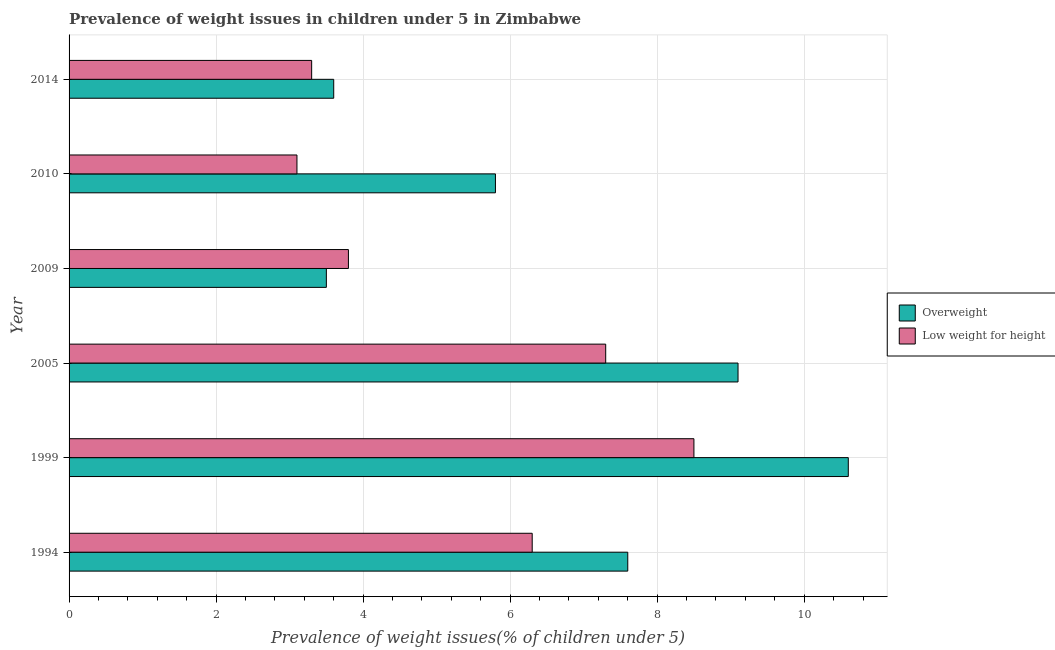How many different coloured bars are there?
Make the answer very short. 2. How many groups of bars are there?
Your response must be concise. 6. How many bars are there on the 4th tick from the top?
Give a very brief answer. 2. What is the percentage of underweight children in 2010?
Your answer should be compact. 3.1. Across all years, what is the maximum percentage of overweight children?
Make the answer very short. 10.6. Across all years, what is the minimum percentage of underweight children?
Ensure brevity in your answer.  3.1. In which year was the percentage of underweight children maximum?
Your answer should be compact. 1999. In which year was the percentage of underweight children minimum?
Offer a terse response. 2010. What is the total percentage of overweight children in the graph?
Your answer should be very brief. 40.2. What is the difference between the percentage of underweight children in 1994 and that in 2009?
Keep it short and to the point. 2.5. What is the difference between the percentage of underweight children in 1994 and the percentage of overweight children in 2010?
Your answer should be compact. 0.5. In the year 1994, what is the difference between the percentage of underweight children and percentage of overweight children?
Provide a short and direct response. -1.3. In how many years, is the percentage of overweight children greater than 2.4 %?
Make the answer very short. 6. What is the ratio of the percentage of underweight children in 2009 to that in 2014?
Give a very brief answer. 1.15. Is the difference between the percentage of overweight children in 1994 and 2014 greater than the difference between the percentage of underweight children in 1994 and 2014?
Give a very brief answer. Yes. What is the difference between the highest and the second highest percentage of overweight children?
Keep it short and to the point. 1.5. Is the sum of the percentage of overweight children in 2010 and 2014 greater than the maximum percentage of underweight children across all years?
Give a very brief answer. Yes. What does the 1st bar from the top in 1999 represents?
Provide a short and direct response. Low weight for height. What does the 1st bar from the bottom in 1999 represents?
Provide a succinct answer. Overweight. How many bars are there?
Provide a succinct answer. 12. Are all the bars in the graph horizontal?
Provide a short and direct response. Yes. How many years are there in the graph?
Offer a very short reply. 6. Are the values on the major ticks of X-axis written in scientific E-notation?
Your answer should be very brief. No. Does the graph contain any zero values?
Make the answer very short. No. Where does the legend appear in the graph?
Offer a very short reply. Center right. How many legend labels are there?
Offer a terse response. 2. How are the legend labels stacked?
Offer a terse response. Vertical. What is the title of the graph?
Your answer should be very brief. Prevalence of weight issues in children under 5 in Zimbabwe. What is the label or title of the X-axis?
Your answer should be compact. Prevalence of weight issues(% of children under 5). What is the label or title of the Y-axis?
Your response must be concise. Year. What is the Prevalence of weight issues(% of children under 5) of Overweight in 1994?
Make the answer very short. 7.6. What is the Prevalence of weight issues(% of children under 5) of Low weight for height in 1994?
Your answer should be very brief. 6.3. What is the Prevalence of weight issues(% of children under 5) in Overweight in 1999?
Your response must be concise. 10.6. What is the Prevalence of weight issues(% of children under 5) of Overweight in 2005?
Your response must be concise. 9.1. What is the Prevalence of weight issues(% of children under 5) of Low weight for height in 2005?
Provide a short and direct response. 7.3. What is the Prevalence of weight issues(% of children under 5) in Overweight in 2009?
Ensure brevity in your answer.  3.5. What is the Prevalence of weight issues(% of children under 5) in Low weight for height in 2009?
Give a very brief answer. 3.8. What is the Prevalence of weight issues(% of children under 5) of Overweight in 2010?
Provide a succinct answer. 5.8. What is the Prevalence of weight issues(% of children under 5) of Low weight for height in 2010?
Your answer should be compact. 3.1. What is the Prevalence of weight issues(% of children under 5) in Overweight in 2014?
Give a very brief answer. 3.6. What is the Prevalence of weight issues(% of children under 5) in Low weight for height in 2014?
Keep it short and to the point. 3.3. Across all years, what is the maximum Prevalence of weight issues(% of children under 5) in Overweight?
Provide a short and direct response. 10.6. Across all years, what is the maximum Prevalence of weight issues(% of children under 5) of Low weight for height?
Provide a short and direct response. 8.5. Across all years, what is the minimum Prevalence of weight issues(% of children under 5) of Overweight?
Your answer should be compact. 3.5. Across all years, what is the minimum Prevalence of weight issues(% of children under 5) of Low weight for height?
Make the answer very short. 3.1. What is the total Prevalence of weight issues(% of children under 5) of Overweight in the graph?
Your response must be concise. 40.2. What is the total Prevalence of weight issues(% of children under 5) in Low weight for height in the graph?
Make the answer very short. 32.3. What is the difference between the Prevalence of weight issues(% of children under 5) of Overweight in 1994 and that in 1999?
Your response must be concise. -3. What is the difference between the Prevalence of weight issues(% of children under 5) in Overweight in 1994 and that in 2009?
Provide a short and direct response. 4.1. What is the difference between the Prevalence of weight issues(% of children under 5) of Overweight in 1994 and that in 2010?
Provide a succinct answer. 1.8. What is the difference between the Prevalence of weight issues(% of children under 5) of Low weight for height in 1994 and that in 2014?
Ensure brevity in your answer.  3. What is the difference between the Prevalence of weight issues(% of children under 5) in Low weight for height in 1999 and that in 2009?
Make the answer very short. 4.7. What is the difference between the Prevalence of weight issues(% of children under 5) of Overweight in 2005 and that in 2009?
Ensure brevity in your answer.  5.6. What is the difference between the Prevalence of weight issues(% of children under 5) in Low weight for height in 2005 and that in 2009?
Your answer should be compact. 3.5. What is the difference between the Prevalence of weight issues(% of children under 5) in Overweight in 2005 and that in 2010?
Make the answer very short. 3.3. What is the difference between the Prevalence of weight issues(% of children under 5) in Low weight for height in 2005 and that in 2010?
Your answer should be compact. 4.2. What is the difference between the Prevalence of weight issues(% of children under 5) in Overweight in 2005 and that in 2014?
Your answer should be very brief. 5.5. What is the difference between the Prevalence of weight issues(% of children under 5) in Overweight in 2009 and that in 2010?
Provide a short and direct response. -2.3. What is the difference between the Prevalence of weight issues(% of children under 5) of Overweight in 2009 and that in 2014?
Your answer should be compact. -0.1. What is the difference between the Prevalence of weight issues(% of children under 5) of Low weight for height in 2009 and that in 2014?
Ensure brevity in your answer.  0.5. What is the difference between the Prevalence of weight issues(% of children under 5) of Low weight for height in 2010 and that in 2014?
Give a very brief answer. -0.2. What is the difference between the Prevalence of weight issues(% of children under 5) of Overweight in 1994 and the Prevalence of weight issues(% of children under 5) of Low weight for height in 2005?
Make the answer very short. 0.3. What is the difference between the Prevalence of weight issues(% of children under 5) in Overweight in 1994 and the Prevalence of weight issues(% of children under 5) in Low weight for height in 2009?
Your response must be concise. 3.8. What is the difference between the Prevalence of weight issues(% of children under 5) of Overweight in 1994 and the Prevalence of weight issues(% of children under 5) of Low weight for height in 2010?
Offer a very short reply. 4.5. What is the difference between the Prevalence of weight issues(% of children under 5) in Overweight in 1994 and the Prevalence of weight issues(% of children under 5) in Low weight for height in 2014?
Keep it short and to the point. 4.3. What is the difference between the Prevalence of weight issues(% of children under 5) of Overweight in 1999 and the Prevalence of weight issues(% of children under 5) of Low weight for height in 2005?
Your answer should be very brief. 3.3. What is the difference between the Prevalence of weight issues(% of children under 5) in Overweight in 1999 and the Prevalence of weight issues(% of children under 5) in Low weight for height in 2009?
Give a very brief answer. 6.8. What is the difference between the Prevalence of weight issues(% of children under 5) in Overweight in 2005 and the Prevalence of weight issues(% of children under 5) in Low weight for height in 2009?
Offer a terse response. 5.3. What is the difference between the Prevalence of weight issues(% of children under 5) in Overweight in 2009 and the Prevalence of weight issues(% of children under 5) in Low weight for height in 2014?
Your answer should be compact. 0.2. What is the difference between the Prevalence of weight issues(% of children under 5) in Overweight in 2010 and the Prevalence of weight issues(% of children under 5) in Low weight for height in 2014?
Offer a terse response. 2.5. What is the average Prevalence of weight issues(% of children under 5) in Low weight for height per year?
Give a very brief answer. 5.38. In the year 1994, what is the difference between the Prevalence of weight issues(% of children under 5) of Overweight and Prevalence of weight issues(% of children under 5) of Low weight for height?
Your answer should be very brief. 1.3. In the year 2010, what is the difference between the Prevalence of weight issues(% of children under 5) of Overweight and Prevalence of weight issues(% of children under 5) of Low weight for height?
Offer a very short reply. 2.7. In the year 2014, what is the difference between the Prevalence of weight issues(% of children under 5) in Overweight and Prevalence of weight issues(% of children under 5) in Low weight for height?
Your response must be concise. 0.3. What is the ratio of the Prevalence of weight issues(% of children under 5) in Overweight in 1994 to that in 1999?
Provide a succinct answer. 0.72. What is the ratio of the Prevalence of weight issues(% of children under 5) in Low weight for height in 1994 to that in 1999?
Your response must be concise. 0.74. What is the ratio of the Prevalence of weight issues(% of children under 5) of Overweight in 1994 to that in 2005?
Your answer should be compact. 0.84. What is the ratio of the Prevalence of weight issues(% of children under 5) of Low weight for height in 1994 to that in 2005?
Offer a very short reply. 0.86. What is the ratio of the Prevalence of weight issues(% of children under 5) in Overweight in 1994 to that in 2009?
Your answer should be compact. 2.17. What is the ratio of the Prevalence of weight issues(% of children under 5) of Low weight for height in 1994 to that in 2009?
Your response must be concise. 1.66. What is the ratio of the Prevalence of weight issues(% of children under 5) in Overweight in 1994 to that in 2010?
Make the answer very short. 1.31. What is the ratio of the Prevalence of weight issues(% of children under 5) of Low weight for height in 1994 to that in 2010?
Ensure brevity in your answer.  2.03. What is the ratio of the Prevalence of weight issues(% of children under 5) of Overweight in 1994 to that in 2014?
Your answer should be compact. 2.11. What is the ratio of the Prevalence of weight issues(% of children under 5) of Low weight for height in 1994 to that in 2014?
Ensure brevity in your answer.  1.91. What is the ratio of the Prevalence of weight issues(% of children under 5) in Overweight in 1999 to that in 2005?
Offer a very short reply. 1.16. What is the ratio of the Prevalence of weight issues(% of children under 5) of Low weight for height in 1999 to that in 2005?
Provide a short and direct response. 1.16. What is the ratio of the Prevalence of weight issues(% of children under 5) of Overweight in 1999 to that in 2009?
Provide a succinct answer. 3.03. What is the ratio of the Prevalence of weight issues(% of children under 5) in Low weight for height in 1999 to that in 2009?
Provide a succinct answer. 2.24. What is the ratio of the Prevalence of weight issues(% of children under 5) of Overweight in 1999 to that in 2010?
Offer a terse response. 1.83. What is the ratio of the Prevalence of weight issues(% of children under 5) of Low weight for height in 1999 to that in 2010?
Offer a terse response. 2.74. What is the ratio of the Prevalence of weight issues(% of children under 5) in Overweight in 1999 to that in 2014?
Make the answer very short. 2.94. What is the ratio of the Prevalence of weight issues(% of children under 5) of Low weight for height in 1999 to that in 2014?
Ensure brevity in your answer.  2.58. What is the ratio of the Prevalence of weight issues(% of children under 5) in Low weight for height in 2005 to that in 2009?
Provide a short and direct response. 1.92. What is the ratio of the Prevalence of weight issues(% of children under 5) of Overweight in 2005 to that in 2010?
Ensure brevity in your answer.  1.57. What is the ratio of the Prevalence of weight issues(% of children under 5) in Low weight for height in 2005 to that in 2010?
Provide a short and direct response. 2.35. What is the ratio of the Prevalence of weight issues(% of children under 5) of Overweight in 2005 to that in 2014?
Ensure brevity in your answer.  2.53. What is the ratio of the Prevalence of weight issues(% of children under 5) in Low weight for height in 2005 to that in 2014?
Offer a very short reply. 2.21. What is the ratio of the Prevalence of weight issues(% of children under 5) in Overweight in 2009 to that in 2010?
Offer a very short reply. 0.6. What is the ratio of the Prevalence of weight issues(% of children under 5) of Low weight for height in 2009 to that in 2010?
Provide a short and direct response. 1.23. What is the ratio of the Prevalence of weight issues(% of children under 5) of Overweight in 2009 to that in 2014?
Make the answer very short. 0.97. What is the ratio of the Prevalence of weight issues(% of children under 5) of Low weight for height in 2009 to that in 2014?
Offer a very short reply. 1.15. What is the ratio of the Prevalence of weight issues(% of children under 5) of Overweight in 2010 to that in 2014?
Your answer should be very brief. 1.61. What is the ratio of the Prevalence of weight issues(% of children under 5) of Low weight for height in 2010 to that in 2014?
Keep it short and to the point. 0.94. What is the difference between the highest and the second highest Prevalence of weight issues(% of children under 5) in Low weight for height?
Offer a terse response. 1.2. What is the difference between the highest and the lowest Prevalence of weight issues(% of children under 5) of Overweight?
Your response must be concise. 7.1. 